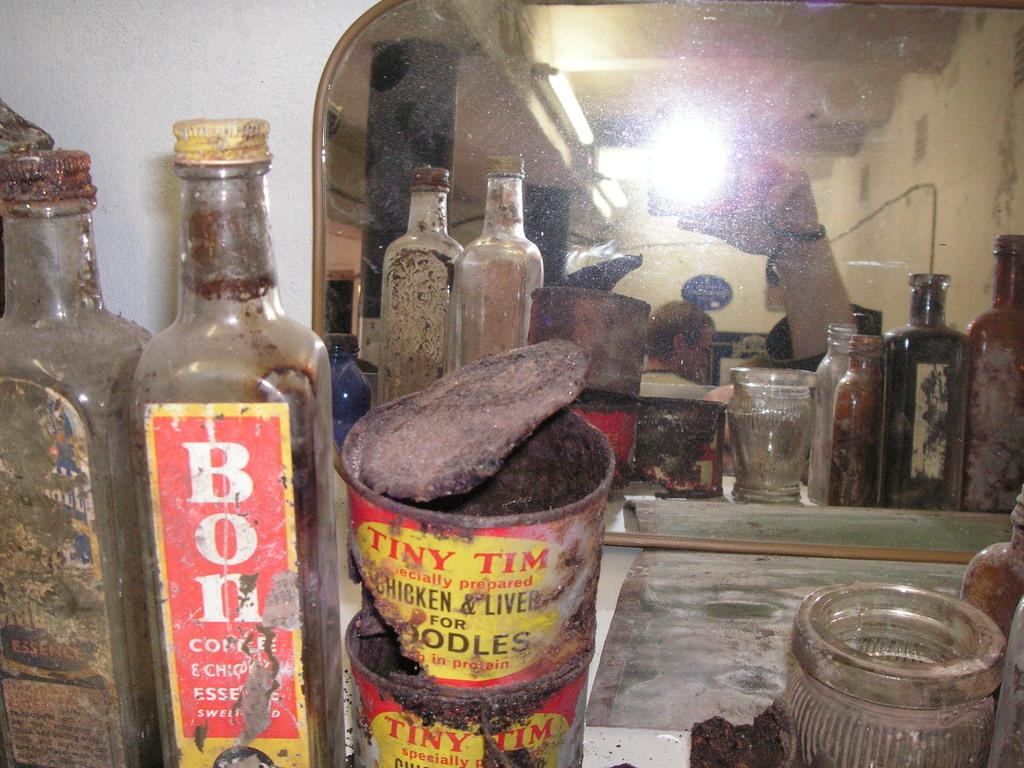<image>
Write a terse but informative summary of the picture. Bottle of Tiny Tim Chicken and liver beside a bottle of Bon 